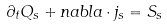<formula> <loc_0><loc_0><loc_500><loc_500>\partial _ { t } Q _ { s } + n a b l a \cdot j _ { s } = S _ { s }</formula> 